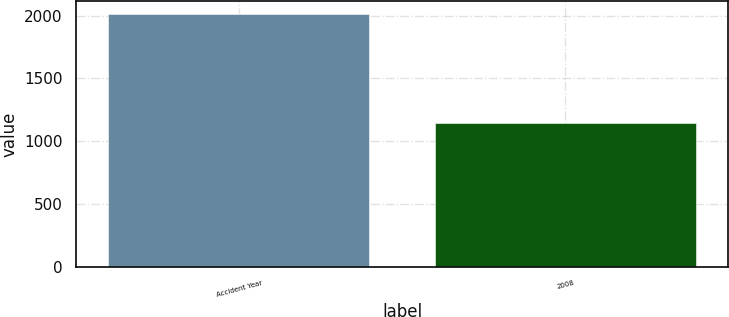Convert chart to OTSL. <chart><loc_0><loc_0><loc_500><loc_500><bar_chart><fcel>Accident Year<fcel>2008<nl><fcel>2014<fcel>1146<nl></chart> 